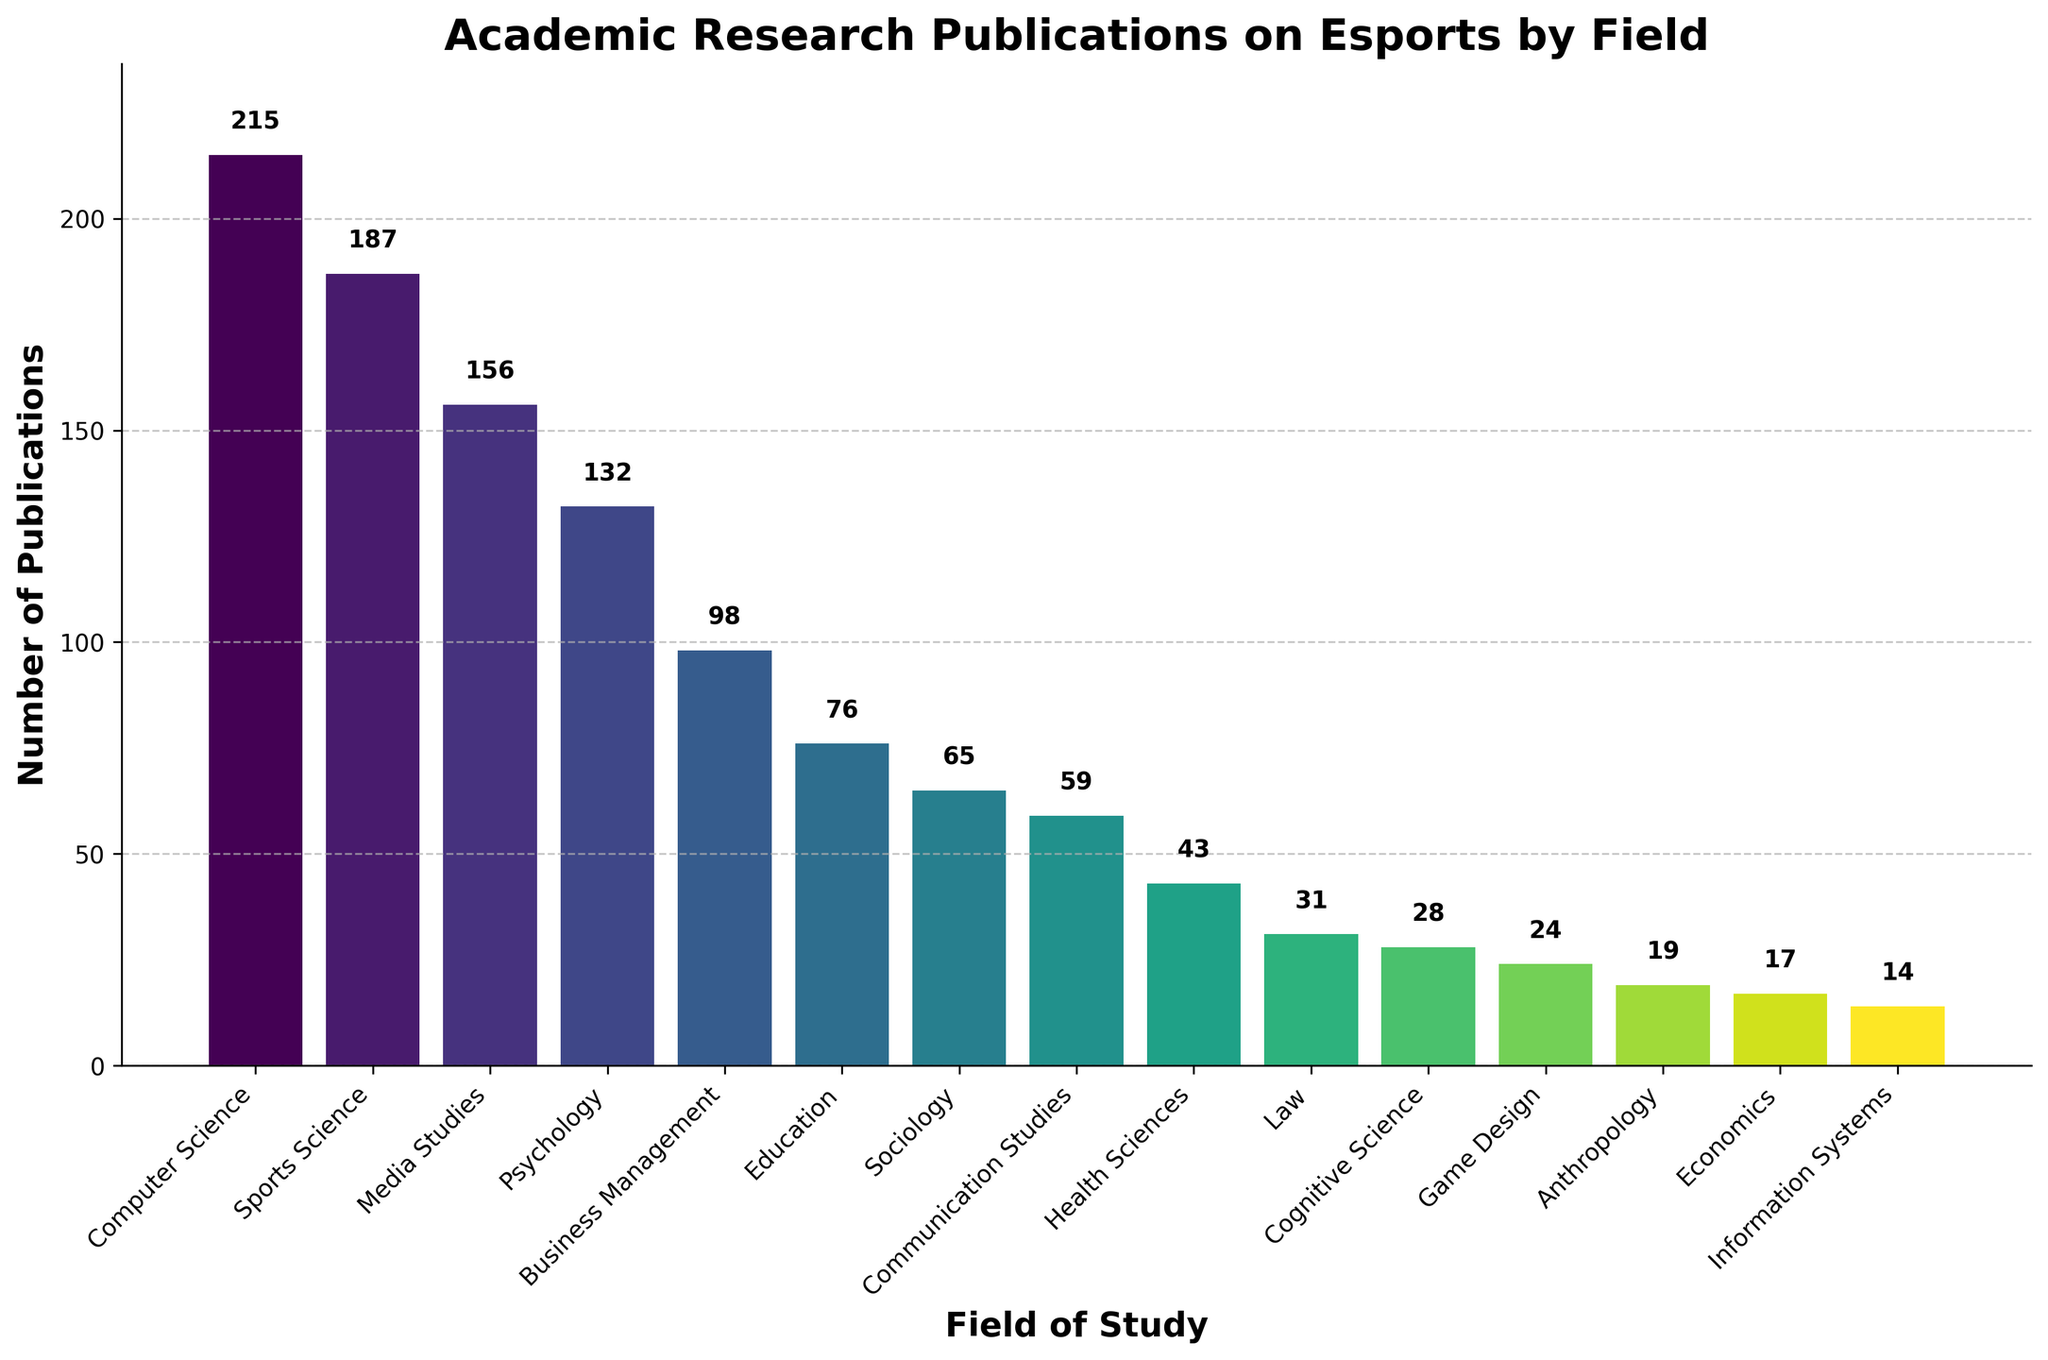Which field has the highest number of publications? The bar labeled 'Computer Science' has the highest bar height, representing the largest number of publications at 215.
Answer: Computer Science Which field has fewer publications, Education or Sociology? Comparing the bar heights for Education (76 publications) and Sociology (65 publications), Sociology has fewer publications.
Answer: Sociology What is the total number of publications for Business Management, Education, and Sociology combined? Adding the number of publications for Business Management (98), Education (76), and Sociology (65) results in a total of 239.
Answer: 239 How much greater is the number of publications in Computer Science compared to Game Design? The difference in the number of publications between Computer Science (215) and Game Design (24) is 215 - 24 = 191.
Answer: 191 Which has more publications, Psychology or Sports Science? Comparing the bar heights, Sports Science has 187 publications while Psychology has 132. Thus, Sports Science has more publications.
Answer: Sports Science What is the average number of publications among Health Sciences, Law, and Cognitive Science? Calculating the average: (43 + 31 + 28) / 3 = 34.
Answer: 34 Which fields have more than 100 publications? Fields with bars exceeding the horizontal line at 100 are Computer Science (215), Sports Science (187), Media Studies (156), and Psychology (132).
Answer: Computer Science, Sports Science, Media Studies, Psychology Are there more publications in Media Studies or Business Management, and by how much? Media Studies has 156 publications, Business Management has 98, the difference is 156 - 98 = 58.
Answer: Media Studies, 58 How does the number of publications in Communication Studies compare to Information Systems? Communication Studies has 59 publications while Information Systems has 14, meaning Communication Studies has more publications.
Answer: Communication Studies 